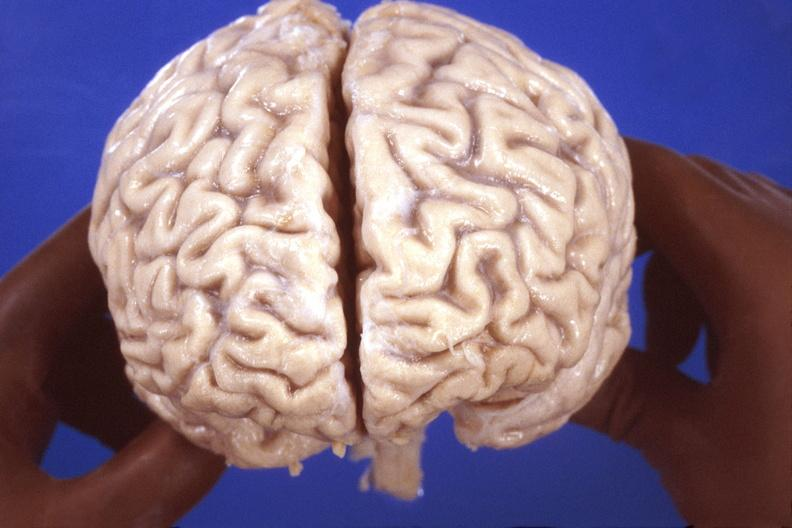what is present?
Answer the question using a single word or phrase. Nervous 